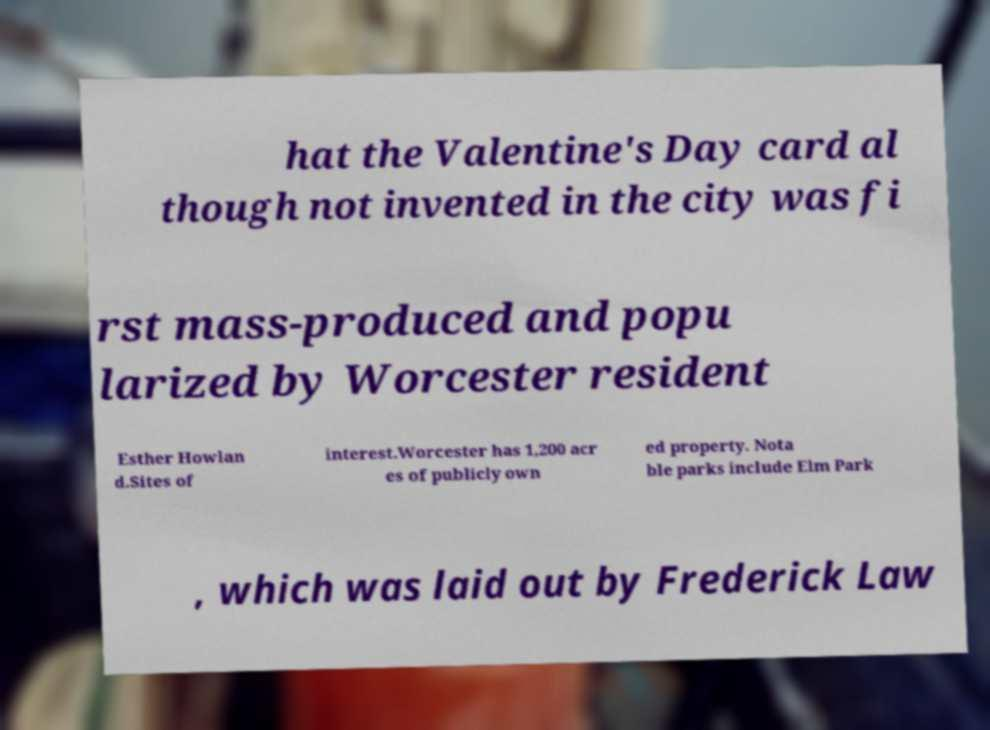I need the written content from this picture converted into text. Can you do that? hat the Valentine's Day card al though not invented in the city was fi rst mass-produced and popu larized by Worcester resident Esther Howlan d.Sites of interest.Worcester has 1,200 acr es of publicly own ed property. Nota ble parks include Elm Park , which was laid out by Frederick Law 